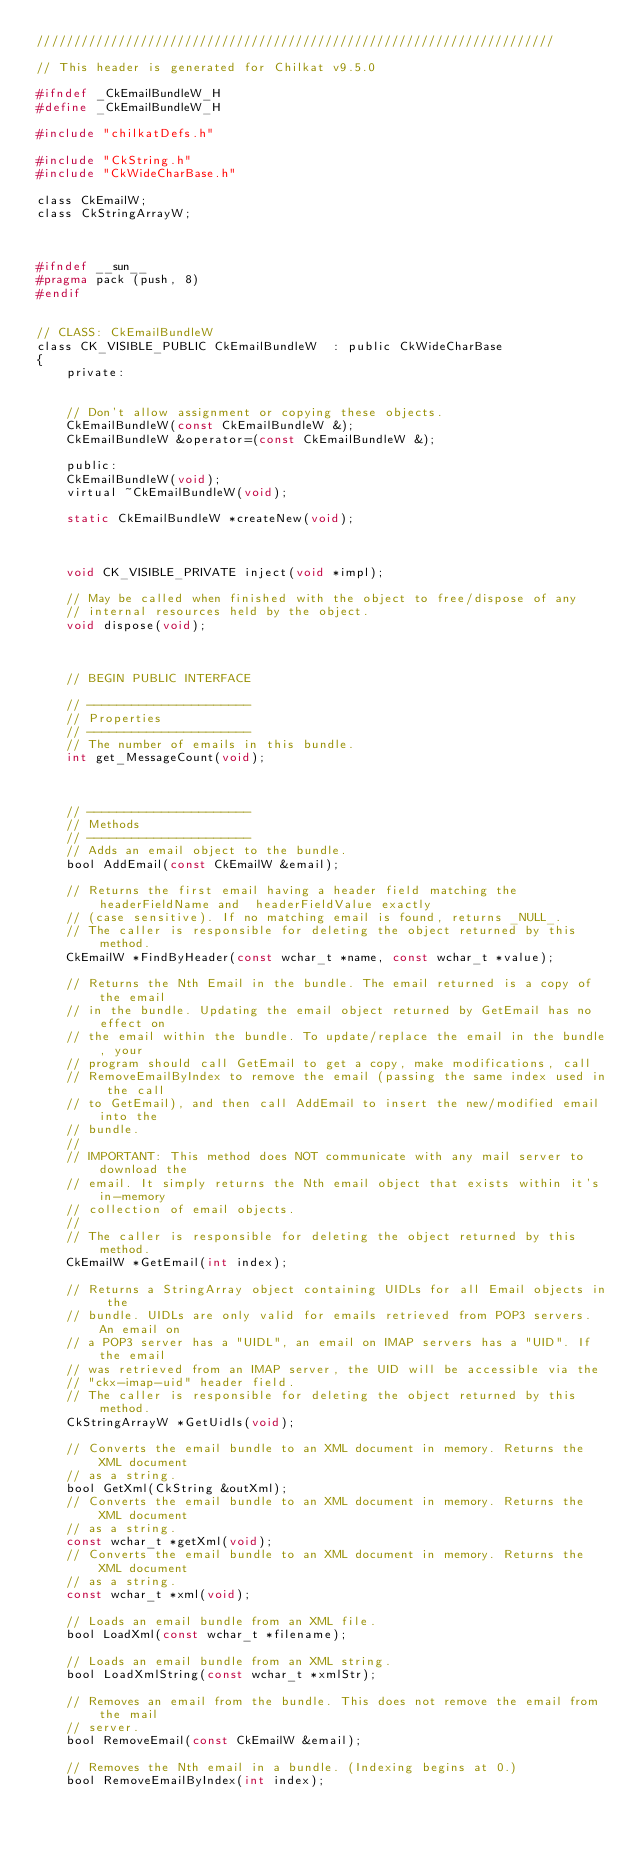<code> <loc_0><loc_0><loc_500><loc_500><_C_>//////////////////////////////////////////////////////////////////////

// This header is generated for Chilkat v9.5.0

#ifndef _CkEmailBundleW_H
#define _CkEmailBundleW_H
	
#include "chilkatDefs.h"

#include "CkString.h"
#include "CkWideCharBase.h"

class CkEmailW;
class CkStringArrayW;



#ifndef __sun__
#pragma pack (push, 8)
#endif
 

// CLASS: CkEmailBundleW
class CK_VISIBLE_PUBLIC CkEmailBundleW  : public CkWideCharBase
{
    private:
	

	// Don't allow assignment or copying these objects.
	CkEmailBundleW(const CkEmailBundleW &);
	CkEmailBundleW &operator=(const CkEmailBundleW &);

    public:
	CkEmailBundleW(void);
	virtual ~CkEmailBundleW(void);

	static CkEmailBundleW *createNew(void);
	

	
	void CK_VISIBLE_PRIVATE inject(void *impl);

	// May be called when finished with the object to free/dispose of any
	// internal resources held by the object. 
	void dispose(void);

	

	// BEGIN PUBLIC INTERFACE

	// ----------------------
	// Properties
	// ----------------------
	// The number of emails in this bundle.
	int get_MessageCount(void);



	// ----------------------
	// Methods
	// ----------------------
	// Adds an email object to the bundle.
	bool AddEmail(const CkEmailW &email);

	// Returns the first email having a header field matching the headerFieldName and  headerFieldValue exactly
	// (case sensitive). If no matching email is found, returns _NULL_.
	// The caller is responsible for deleting the object returned by this method.
	CkEmailW *FindByHeader(const wchar_t *name, const wchar_t *value);

	// Returns the Nth Email in the bundle. The email returned is a copy of the email
	// in the bundle. Updating the email object returned by GetEmail has no effect on
	// the email within the bundle. To update/replace the email in the bundle, your
	// program should call GetEmail to get a copy, make modifications, call
	// RemoveEmailByIndex to remove the email (passing the same index used in the call
	// to GetEmail), and then call AddEmail to insert the new/modified email into the
	// bundle.
	// 
	// IMPORTANT: This method does NOT communicate with any mail server to download the
	// email. It simply returns the Nth email object that exists within it's in-memory
	// collection of email objects.
	// 
	// The caller is responsible for deleting the object returned by this method.
	CkEmailW *GetEmail(int index);

	// Returns a StringArray object containing UIDLs for all Email objects in the
	// bundle. UIDLs are only valid for emails retrieved from POP3 servers. An email on
	// a POP3 server has a "UIDL", an email on IMAP servers has a "UID". If the email
	// was retrieved from an IMAP server, the UID will be accessible via the
	// "ckx-imap-uid" header field.
	// The caller is responsible for deleting the object returned by this method.
	CkStringArrayW *GetUidls(void);

	// Converts the email bundle to an XML document in memory. Returns the XML document
	// as a string.
	bool GetXml(CkString &outXml);
	// Converts the email bundle to an XML document in memory. Returns the XML document
	// as a string.
	const wchar_t *getXml(void);
	// Converts the email bundle to an XML document in memory. Returns the XML document
	// as a string.
	const wchar_t *xml(void);

	// Loads an email bundle from an XML file.
	bool LoadXml(const wchar_t *filename);

	// Loads an email bundle from an XML string.
	bool LoadXmlString(const wchar_t *xmlStr);

	// Removes an email from the bundle. This does not remove the email from the mail
	// server.
	bool RemoveEmail(const CkEmailW &email);

	// Removes the Nth email in a bundle. (Indexing begins at 0.)
	bool RemoveEmailByIndex(int index);
</code> 